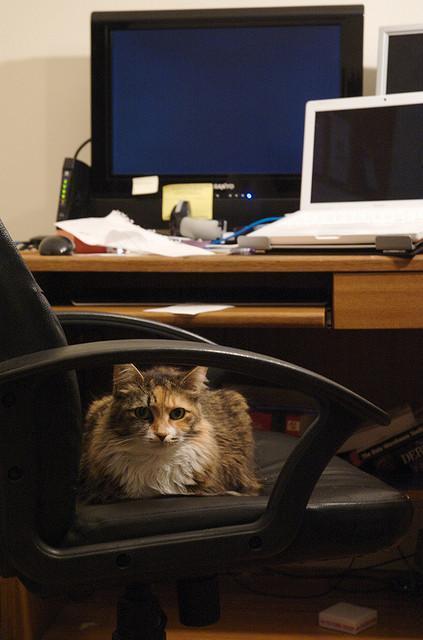How many screens?
Give a very brief answer. 3. How many keyboards are visible?
Give a very brief answer. 1. 